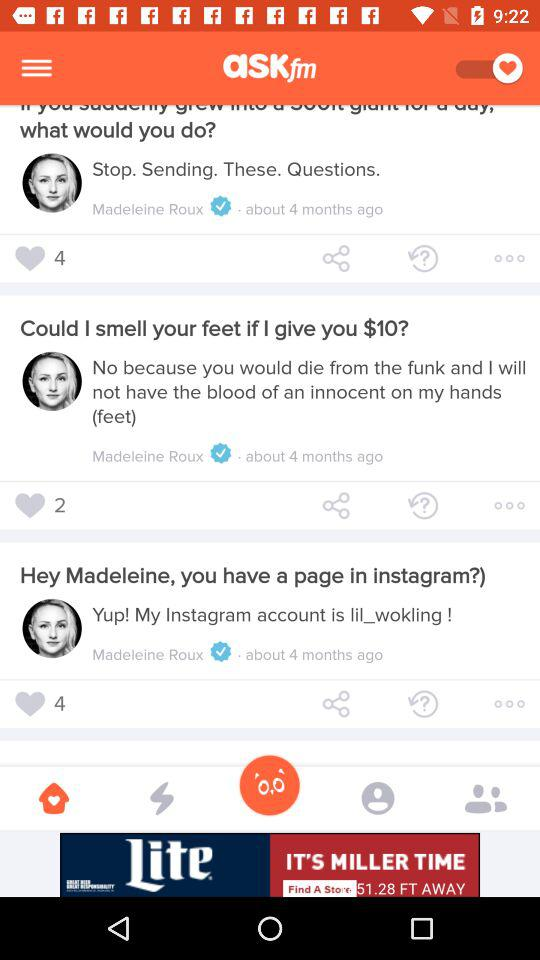How many hearts does the question 'Could I smell your feet if I give you $10?' have?
Answer the question using a single word or phrase. 2 